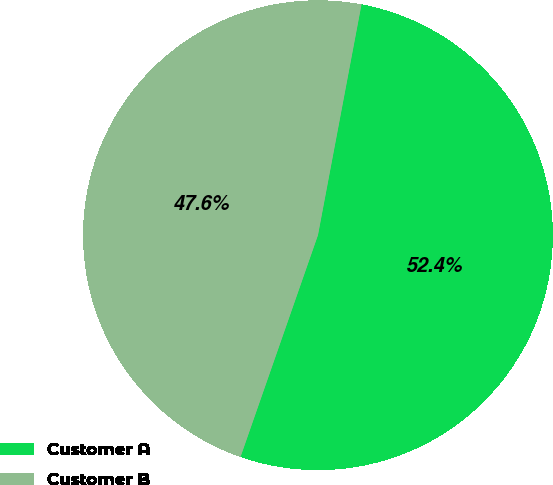Convert chart to OTSL. <chart><loc_0><loc_0><loc_500><loc_500><pie_chart><fcel>Customer A<fcel>Customer B<nl><fcel>52.38%<fcel>47.62%<nl></chart> 